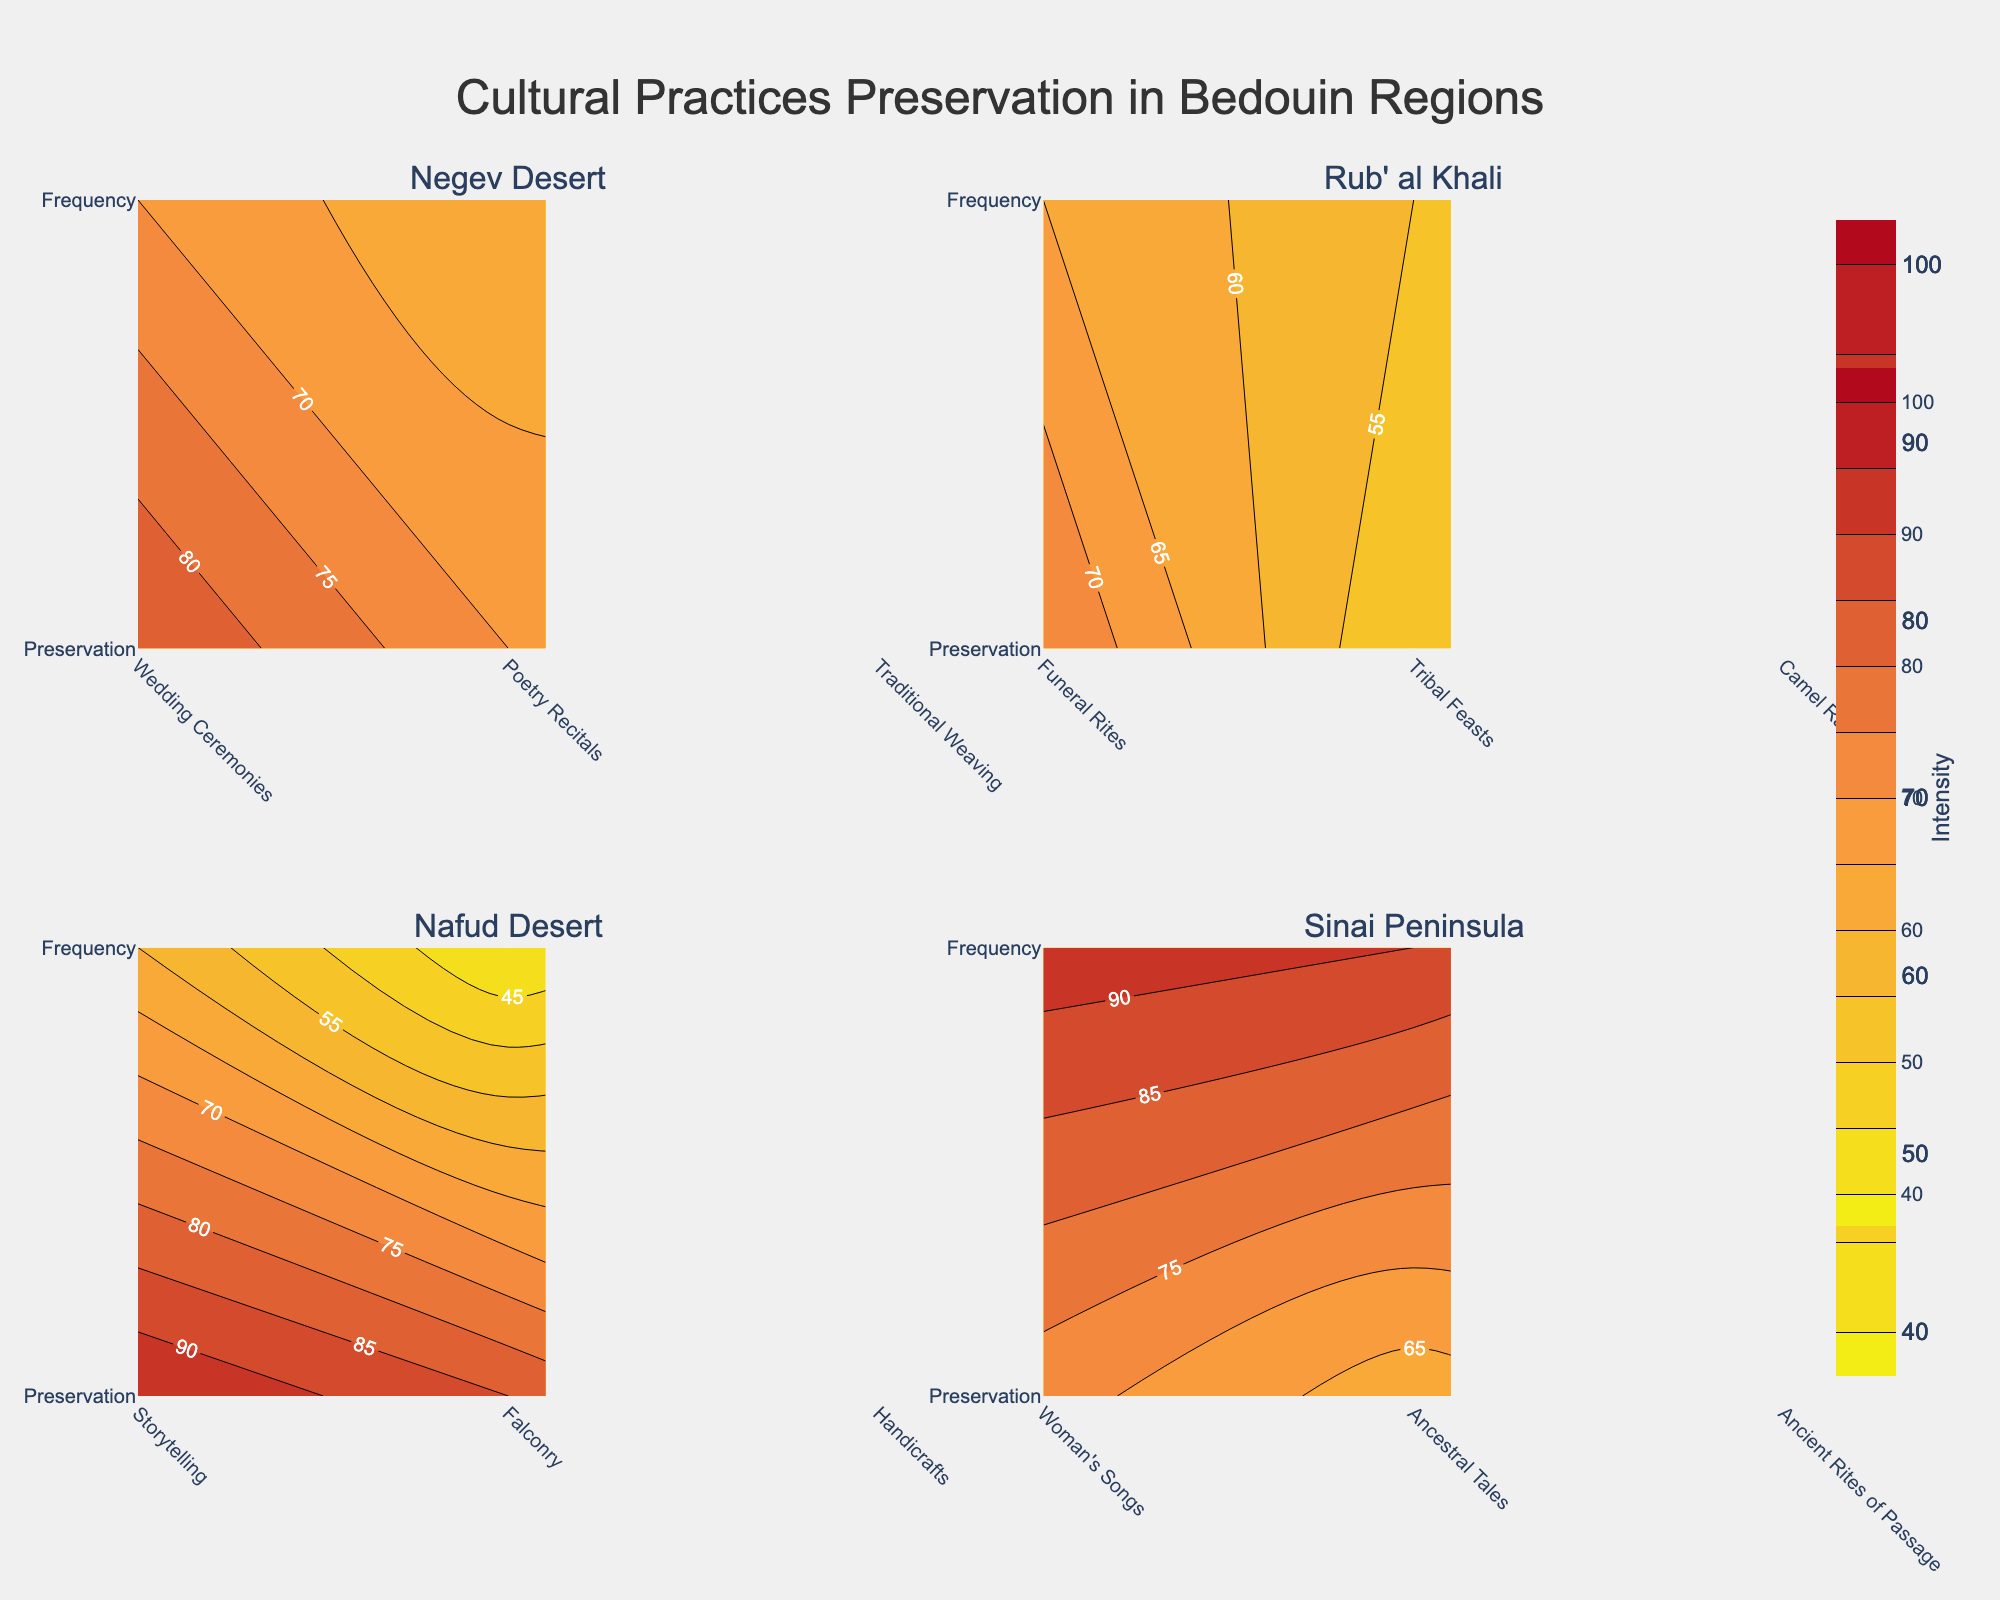What is the title of the figure? The title is prominently displayed at the top of the figure, right in the center. It reads, "Cultural Practices Preservation in Bedouin Regions."
Answer: Cultural Practices Preservation in Bedouin Regions Which region has the highest level of preservation efforts for a tradition? By examining the highest preservation efforts in each subplot, we find “Traditional Weaving” in the Negev Desert has the highest value of 90.
Answer: Negev Desert for Traditional Weaving In which region is "Storytelling" practiced and how frequently is it mentioned? Find "Storytelling" on the x-axis and note its frequency from the y-axis or associated contours. It is present in the Nafud Desert and has a frequency of 85.
Answer: Nafud Desert, 85 What is the average preservation effort for traditions in the Sinai Peninsula? Sum the preservation efforts for the three traditions in the Sinai Peninsula (72, 93, and 70) and divide by 3. (72 + 93 + 70) / 3 = 235 / 3 = 78.33.
Answer: 78.33 Compare the Frequency of Mention for "Camel Racing" in Rub' al Khali with "Falconry" in the Nafud Desert. Which is higher? Look at the frequency values for “Camel Racing” and “Falconry” from their respective contours; Camel Racing is 65 and Falconry is 40. “Camel Racing” in Rub' al Khali is higher.
Answer: Camel Racing in Rub' al Khali Which tradition has the closest preservation effort in both Negev Desert and Sinai Peninsula? Compare the contour levels for each tradition in both regions. "Traditional Weaving" in Negev Desert has 90, and the closest in Sinai Peninsula is "Ancestral Tales" with 93.
Answer: Traditional Weaving in Negev Desert and Ancestral Tales in Sinai Peninsula What is the difference in the Frequency of Mention between "Funeral Rites" and "Tribal Feasts" in Rub' al Khali? Identify the frequency values for both: "Funeral Rites" is 50, and "Tribal Feasts" is 55. The difference is 55 - 50 = 5.
Answer: 5 What tradition in Negev Desert has the highest Frequency of Mention? By examining the contour levels for frequency specifically in the Negev Desert subplot, “Traditional Weaving” has the highest frequency of 80.
Answer: Traditional Weaving 